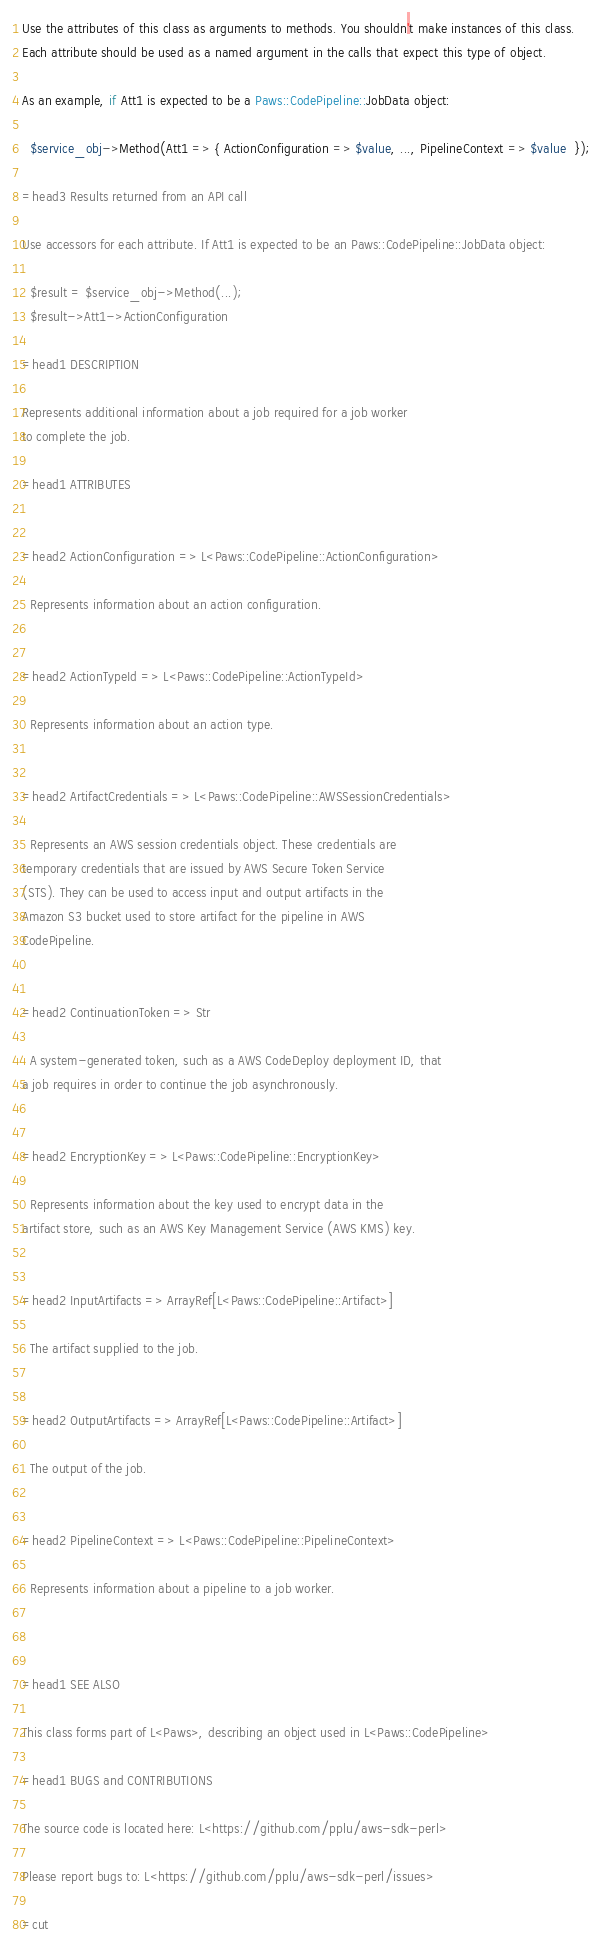Convert code to text. <code><loc_0><loc_0><loc_500><loc_500><_Perl_>
Use the attributes of this class as arguments to methods. You shouldn't make instances of this class. 
Each attribute should be used as a named argument in the calls that expect this type of object.

As an example, if Att1 is expected to be a Paws::CodePipeline::JobData object:

  $service_obj->Method(Att1 => { ActionConfiguration => $value, ..., PipelineContext => $value  });

=head3 Results returned from an API call

Use accessors for each attribute. If Att1 is expected to be an Paws::CodePipeline::JobData object:

  $result = $service_obj->Method(...);
  $result->Att1->ActionConfiguration

=head1 DESCRIPTION

Represents additional information about a job required for a job worker
to complete the job.

=head1 ATTRIBUTES


=head2 ActionConfiguration => L<Paws::CodePipeline::ActionConfiguration>

  Represents information about an action configuration.


=head2 ActionTypeId => L<Paws::CodePipeline::ActionTypeId>

  Represents information about an action type.


=head2 ArtifactCredentials => L<Paws::CodePipeline::AWSSessionCredentials>

  Represents an AWS session credentials object. These credentials are
temporary credentials that are issued by AWS Secure Token Service
(STS). They can be used to access input and output artifacts in the
Amazon S3 bucket used to store artifact for the pipeline in AWS
CodePipeline.


=head2 ContinuationToken => Str

  A system-generated token, such as a AWS CodeDeploy deployment ID, that
a job requires in order to continue the job asynchronously.


=head2 EncryptionKey => L<Paws::CodePipeline::EncryptionKey>

  Represents information about the key used to encrypt data in the
artifact store, such as an AWS Key Management Service (AWS KMS) key.


=head2 InputArtifacts => ArrayRef[L<Paws::CodePipeline::Artifact>]

  The artifact supplied to the job.


=head2 OutputArtifacts => ArrayRef[L<Paws::CodePipeline::Artifact>]

  The output of the job.


=head2 PipelineContext => L<Paws::CodePipeline::PipelineContext>

  Represents information about a pipeline to a job worker.



=head1 SEE ALSO

This class forms part of L<Paws>, describing an object used in L<Paws::CodePipeline>

=head1 BUGS and CONTRIBUTIONS

The source code is located here: L<https://github.com/pplu/aws-sdk-perl>

Please report bugs to: L<https://github.com/pplu/aws-sdk-perl/issues>

=cut

</code> 